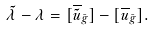<formula> <loc_0><loc_0><loc_500><loc_500>\tilde { \lambda } - \lambda = [ \overline { \tilde { u } } _ { \bar { g } } ] - [ \overline { u } _ { \bar { g } } ] .</formula> 